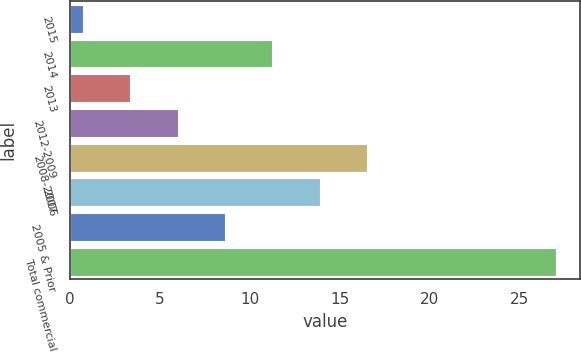Convert chart to OTSL. <chart><loc_0><loc_0><loc_500><loc_500><bar_chart><fcel>2015<fcel>2014<fcel>2013<fcel>2012-2009<fcel>2008-2007<fcel>2006<fcel>2005 & Prior<fcel>Total commercial<nl><fcel>0.73<fcel>11.25<fcel>3.36<fcel>5.99<fcel>16.51<fcel>13.88<fcel>8.62<fcel>27<nl></chart> 